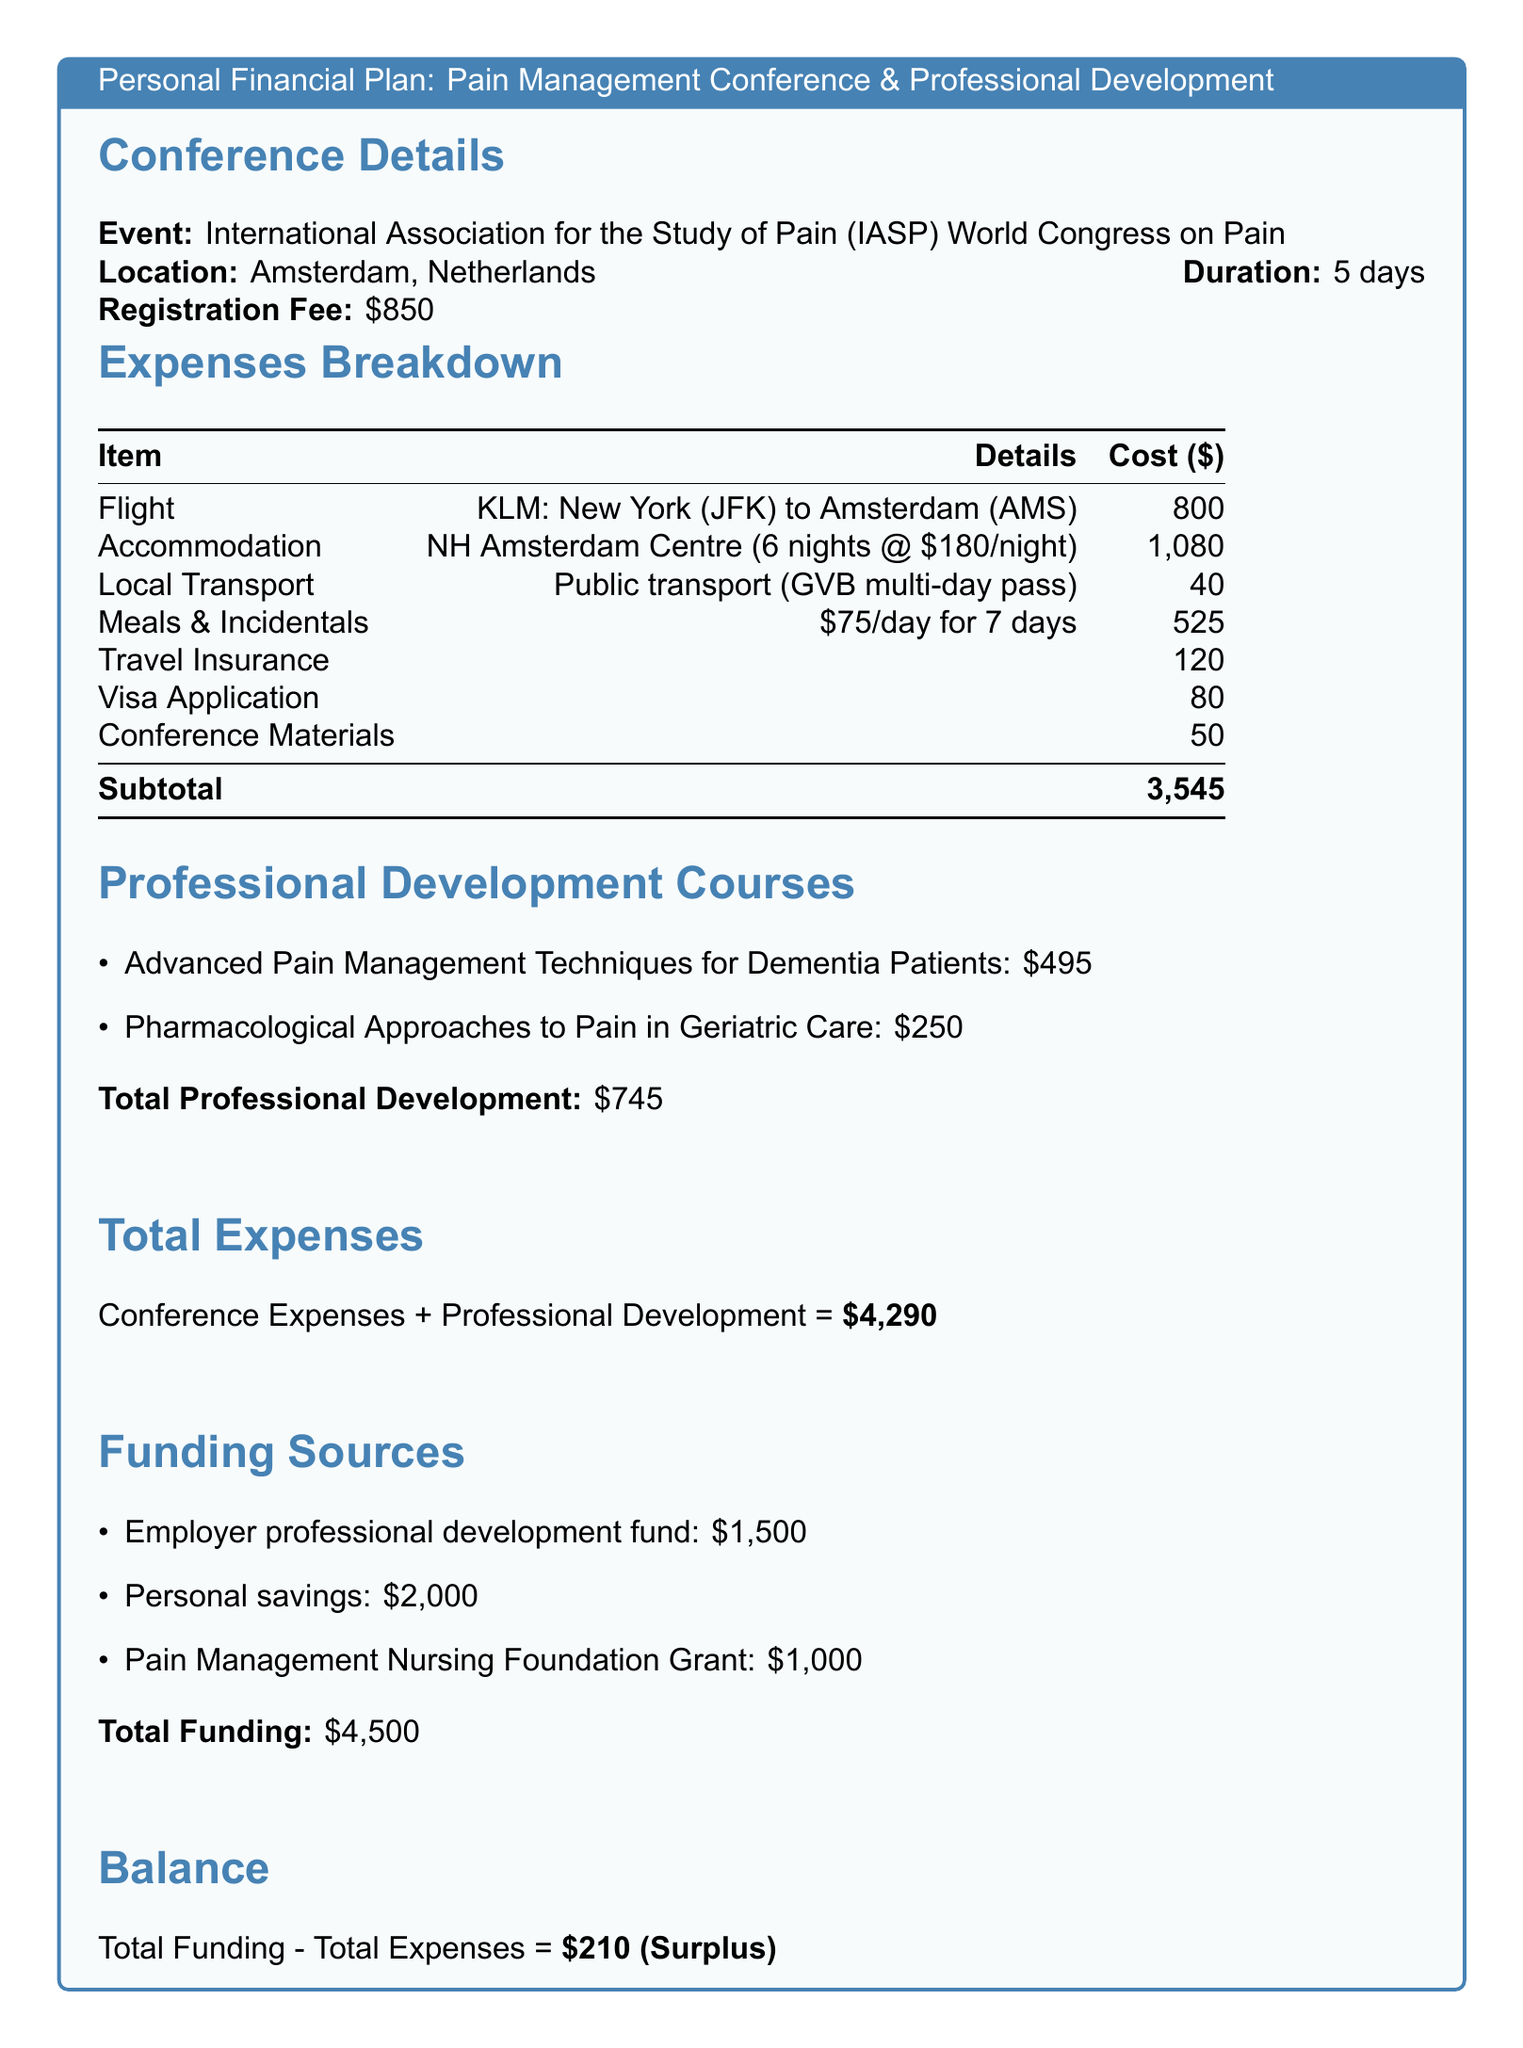What is the registration fee for the conference? The registration fee is explicitly stated in the document.
Answer: $850 How many nights will the accommodation be booked for? The document specifies the accommodation details including the number of nights.
Answer: 6 nights What is the total cost for meals and incidentals? The total for meals and incidentals is computed based on the daily allowance and duration.
Answer: $525 What is the cost of the Advanced Pain Management Techniques for Dementia Patients course? The document lists the price for each professional development course.
Answer: $495 What is the total funding amount? The total funding amount is presented as the sum of all listed funding sources.
Answer: $4,500 What is the total expense for the conference and professional development combined? The document provides a clear calculation of total expenses at the end.
Answer: $4,290 What is the surplus amount after funding? The balance calculation is shown in the document, revealing the surplus.
Answer: $210 What type of grant is included as a funding source? The document identifies the specific grant listed under funding sources.
Answer: Pain Management Nursing Foundation Grant What is the flight cost from New York to Amsterdam? The document specifies the flight cost in the expenses breakdown.
Answer: $800 